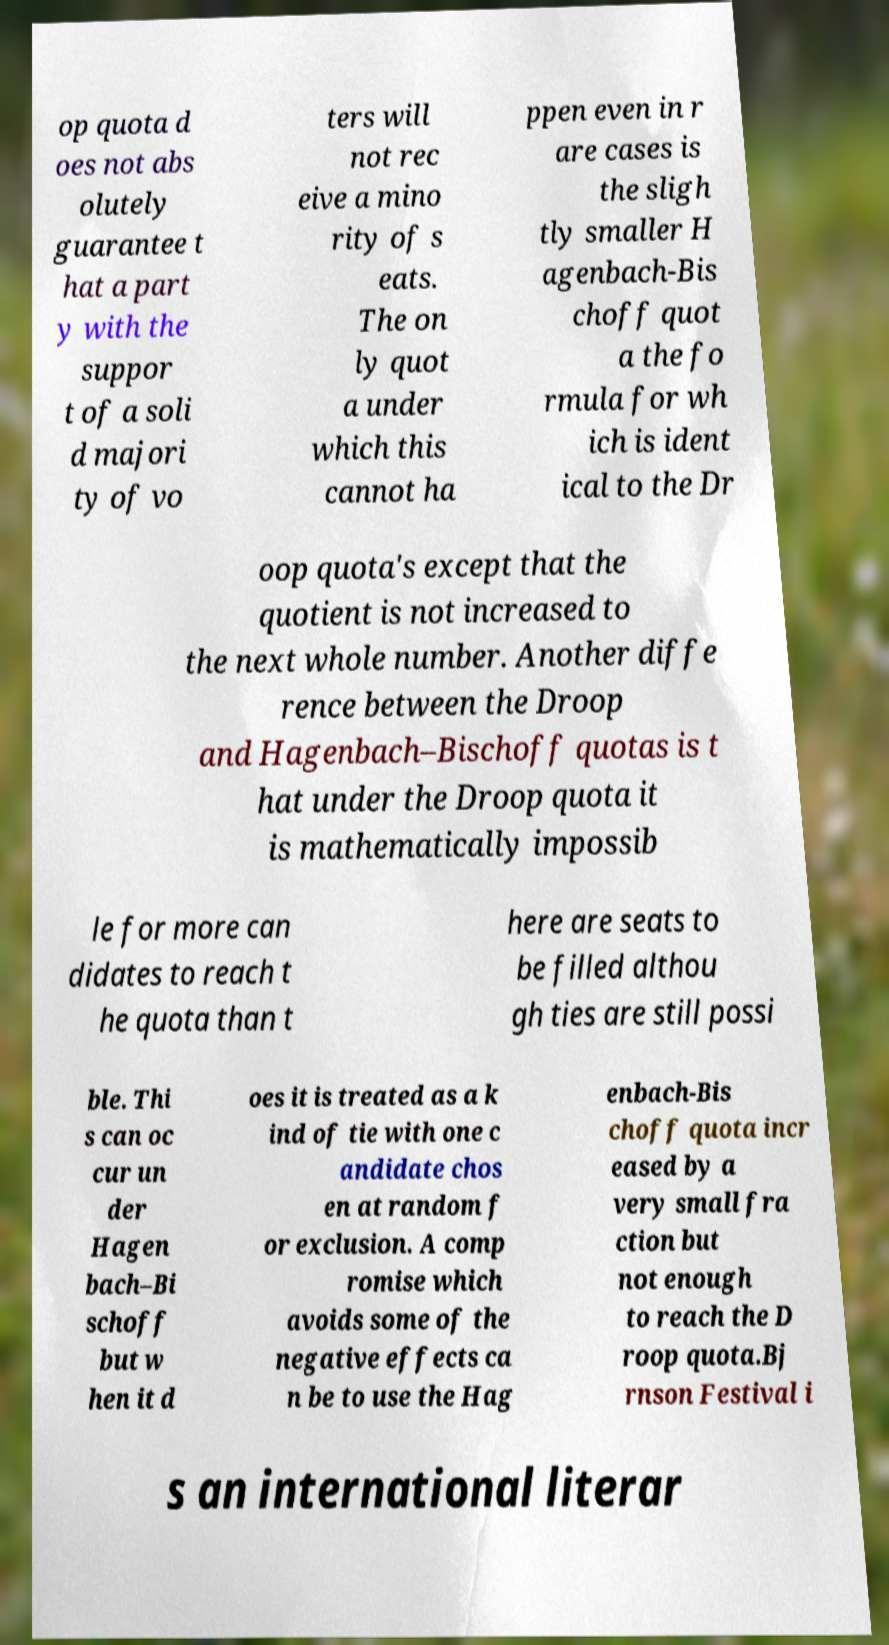Please read and relay the text visible in this image. What does it say? op quota d oes not abs olutely guarantee t hat a part y with the suppor t of a soli d majori ty of vo ters will not rec eive a mino rity of s eats. The on ly quot a under which this cannot ha ppen even in r are cases is the sligh tly smaller H agenbach-Bis choff quot a the fo rmula for wh ich is ident ical to the Dr oop quota's except that the quotient is not increased to the next whole number. Another diffe rence between the Droop and Hagenbach–Bischoff quotas is t hat under the Droop quota it is mathematically impossib le for more can didates to reach t he quota than t here are seats to be filled althou gh ties are still possi ble. Thi s can oc cur un der Hagen bach–Bi schoff but w hen it d oes it is treated as a k ind of tie with one c andidate chos en at random f or exclusion. A comp romise which avoids some of the negative effects ca n be to use the Hag enbach-Bis choff quota incr eased by a very small fra ction but not enough to reach the D roop quota.Bj rnson Festival i s an international literar 